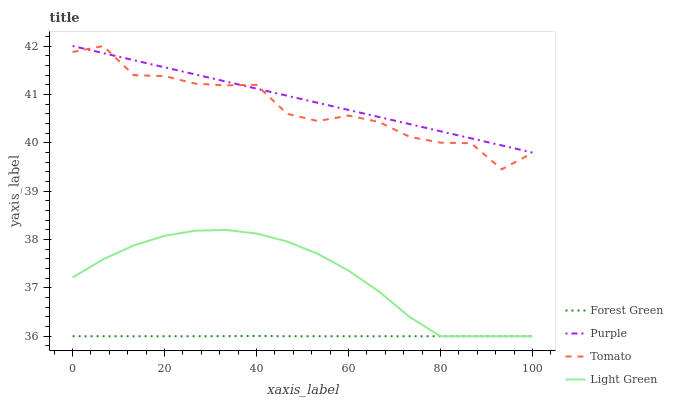Does Tomato have the minimum area under the curve?
Answer yes or no. No. Does Tomato have the maximum area under the curve?
Answer yes or no. No. Is Forest Green the smoothest?
Answer yes or no. No. Is Forest Green the roughest?
Answer yes or no. No. Does Tomato have the lowest value?
Answer yes or no. No. Does Forest Green have the highest value?
Answer yes or no. No. Is Light Green less than Purple?
Answer yes or no. Yes. Is Purple greater than Light Green?
Answer yes or no. Yes. Does Light Green intersect Purple?
Answer yes or no. No. 